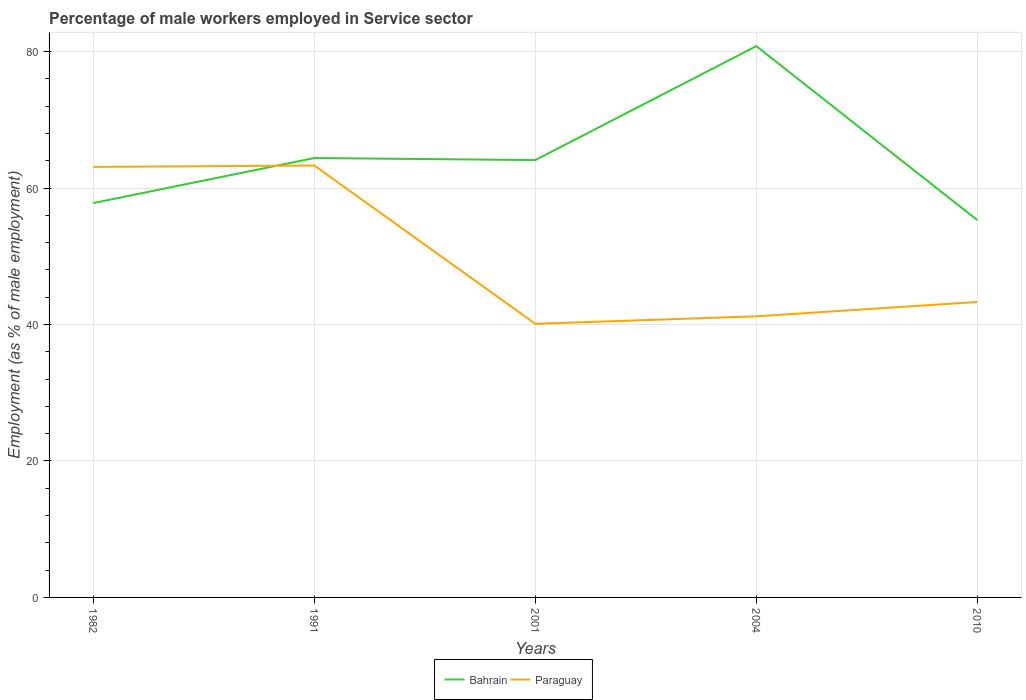Is the number of lines equal to the number of legend labels?
Your response must be concise. Yes. Across all years, what is the maximum percentage of male workers employed in Service sector in Bahrain?
Offer a terse response. 55.3. What is the total percentage of male workers employed in Service sector in Bahrain in the graph?
Make the answer very short. 8.8. What is the difference between the highest and the second highest percentage of male workers employed in Service sector in Bahrain?
Provide a short and direct response. 25.5. Is the percentage of male workers employed in Service sector in Paraguay strictly greater than the percentage of male workers employed in Service sector in Bahrain over the years?
Give a very brief answer. No. How many lines are there?
Your answer should be compact. 2. How many years are there in the graph?
Make the answer very short. 5. Does the graph contain grids?
Ensure brevity in your answer.  Yes. How are the legend labels stacked?
Provide a short and direct response. Horizontal. What is the title of the graph?
Make the answer very short. Percentage of male workers employed in Service sector. Does "Euro area" appear as one of the legend labels in the graph?
Offer a terse response. No. What is the label or title of the Y-axis?
Your answer should be very brief. Employment (as % of male employment). What is the Employment (as % of male employment) of Bahrain in 1982?
Give a very brief answer. 57.8. What is the Employment (as % of male employment) of Paraguay in 1982?
Provide a short and direct response. 63.1. What is the Employment (as % of male employment) of Bahrain in 1991?
Keep it short and to the point. 64.4. What is the Employment (as % of male employment) of Paraguay in 1991?
Your answer should be compact. 63.3. What is the Employment (as % of male employment) of Bahrain in 2001?
Your answer should be very brief. 64.1. What is the Employment (as % of male employment) in Paraguay in 2001?
Offer a very short reply. 40.1. What is the Employment (as % of male employment) of Bahrain in 2004?
Your answer should be very brief. 80.8. What is the Employment (as % of male employment) of Paraguay in 2004?
Provide a short and direct response. 41.2. What is the Employment (as % of male employment) of Bahrain in 2010?
Provide a succinct answer. 55.3. What is the Employment (as % of male employment) in Paraguay in 2010?
Your answer should be compact. 43.3. Across all years, what is the maximum Employment (as % of male employment) in Bahrain?
Give a very brief answer. 80.8. Across all years, what is the maximum Employment (as % of male employment) of Paraguay?
Provide a succinct answer. 63.3. Across all years, what is the minimum Employment (as % of male employment) of Bahrain?
Your answer should be very brief. 55.3. Across all years, what is the minimum Employment (as % of male employment) in Paraguay?
Provide a short and direct response. 40.1. What is the total Employment (as % of male employment) of Bahrain in the graph?
Give a very brief answer. 322.4. What is the total Employment (as % of male employment) of Paraguay in the graph?
Keep it short and to the point. 251. What is the difference between the Employment (as % of male employment) of Bahrain in 1982 and that in 2001?
Ensure brevity in your answer.  -6.3. What is the difference between the Employment (as % of male employment) of Paraguay in 1982 and that in 2001?
Give a very brief answer. 23. What is the difference between the Employment (as % of male employment) in Paraguay in 1982 and that in 2004?
Ensure brevity in your answer.  21.9. What is the difference between the Employment (as % of male employment) of Paraguay in 1982 and that in 2010?
Make the answer very short. 19.8. What is the difference between the Employment (as % of male employment) of Bahrain in 1991 and that in 2001?
Your response must be concise. 0.3. What is the difference between the Employment (as % of male employment) in Paraguay in 1991 and that in 2001?
Your answer should be very brief. 23.2. What is the difference between the Employment (as % of male employment) in Bahrain in 1991 and that in 2004?
Ensure brevity in your answer.  -16.4. What is the difference between the Employment (as % of male employment) of Paraguay in 1991 and that in 2004?
Make the answer very short. 22.1. What is the difference between the Employment (as % of male employment) in Bahrain in 2001 and that in 2004?
Make the answer very short. -16.7. What is the difference between the Employment (as % of male employment) in Paraguay in 2001 and that in 2004?
Offer a terse response. -1.1. What is the difference between the Employment (as % of male employment) in Bahrain in 2001 and that in 2010?
Your answer should be very brief. 8.8. What is the difference between the Employment (as % of male employment) in Bahrain in 2004 and that in 2010?
Your answer should be compact. 25.5. What is the difference between the Employment (as % of male employment) in Bahrain in 1982 and the Employment (as % of male employment) in Paraguay in 1991?
Keep it short and to the point. -5.5. What is the difference between the Employment (as % of male employment) in Bahrain in 1982 and the Employment (as % of male employment) in Paraguay in 2001?
Give a very brief answer. 17.7. What is the difference between the Employment (as % of male employment) in Bahrain in 1982 and the Employment (as % of male employment) in Paraguay in 2004?
Your answer should be very brief. 16.6. What is the difference between the Employment (as % of male employment) of Bahrain in 1991 and the Employment (as % of male employment) of Paraguay in 2001?
Provide a succinct answer. 24.3. What is the difference between the Employment (as % of male employment) in Bahrain in 1991 and the Employment (as % of male employment) in Paraguay in 2004?
Provide a short and direct response. 23.2. What is the difference between the Employment (as % of male employment) in Bahrain in 1991 and the Employment (as % of male employment) in Paraguay in 2010?
Provide a short and direct response. 21.1. What is the difference between the Employment (as % of male employment) in Bahrain in 2001 and the Employment (as % of male employment) in Paraguay in 2004?
Give a very brief answer. 22.9. What is the difference between the Employment (as % of male employment) of Bahrain in 2001 and the Employment (as % of male employment) of Paraguay in 2010?
Make the answer very short. 20.8. What is the difference between the Employment (as % of male employment) in Bahrain in 2004 and the Employment (as % of male employment) in Paraguay in 2010?
Make the answer very short. 37.5. What is the average Employment (as % of male employment) of Bahrain per year?
Your response must be concise. 64.48. What is the average Employment (as % of male employment) of Paraguay per year?
Provide a succinct answer. 50.2. In the year 1991, what is the difference between the Employment (as % of male employment) in Bahrain and Employment (as % of male employment) in Paraguay?
Provide a succinct answer. 1.1. In the year 2001, what is the difference between the Employment (as % of male employment) in Bahrain and Employment (as % of male employment) in Paraguay?
Provide a succinct answer. 24. In the year 2004, what is the difference between the Employment (as % of male employment) in Bahrain and Employment (as % of male employment) in Paraguay?
Give a very brief answer. 39.6. What is the ratio of the Employment (as % of male employment) of Bahrain in 1982 to that in 1991?
Keep it short and to the point. 0.9. What is the ratio of the Employment (as % of male employment) of Paraguay in 1982 to that in 1991?
Make the answer very short. 1. What is the ratio of the Employment (as % of male employment) of Bahrain in 1982 to that in 2001?
Provide a succinct answer. 0.9. What is the ratio of the Employment (as % of male employment) in Paraguay in 1982 to that in 2001?
Your answer should be compact. 1.57. What is the ratio of the Employment (as % of male employment) in Bahrain in 1982 to that in 2004?
Offer a very short reply. 0.72. What is the ratio of the Employment (as % of male employment) of Paraguay in 1982 to that in 2004?
Give a very brief answer. 1.53. What is the ratio of the Employment (as % of male employment) of Bahrain in 1982 to that in 2010?
Offer a very short reply. 1.05. What is the ratio of the Employment (as % of male employment) in Paraguay in 1982 to that in 2010?
Your answer should be very brief. 1.46. What is the ratio of the Employment (as % of male employment) of Bahrain in 1991 to that in 2001?
Your answer should be very brief. 1. What is the ratio of the Employment (as % of male employment) of Paraguay in 1991 to that in 2001?
Offer a terse response. 1.58. What is the ratio of the Employment (as % of male employment) in Bahrain in 1991 to that in 2004?
Give a very brief answer. 0.8. What is the ratio of the Employment (as % of male employment) of Paraguay in 1991 to that in 2004?
Your answer should be very brief. 1.54. What is the ratio of the Employment (as % of male employment) of Bahrain in 1991 to that in 2010?
Give a very brief answer. 1.16. What is the ratio of the Employment (as % of male employment) of Paraguay in 1991 to that in 2010?
Your response must be concise. 1.46. What is the ratio of the Employment (as % of male employment) of Bahrain in 2001 to that in 2004?
Make the answer very short. 0.79. What is the ratio of the Employment (as % of male employment) in Paraguay in 2001 to that in 2004?
Offer a very short reply. 0.97. What is the ratio of the Employment (as % of male employment) in Bahrain in 2001 to that in 2010?
Provide a succinct answer. 1.16. What is the ratio of the Employment (as % of male employment) of Paraguay in 2001 to that in 2010?
Offer a very short reply. 0.93. What is the ratio of the Employment (as % of male employment) in Bahrain in 2004 to that in 2010?
Offer a very short reply. 1.46. What is the ratio of the Employment (as % of male employment) of Paraguay in 2004 to that in 2010?
Your response must be concise. 0.95. What is the difference between the highest and the lowest Employment (as % of male employment) of Bahrain?
Ensure brevity in your answer.  25.5. What is the difference between the highest and the lowest Employment (as % of male employment) of Paraguay?
Your response must be concise. 23.2. 